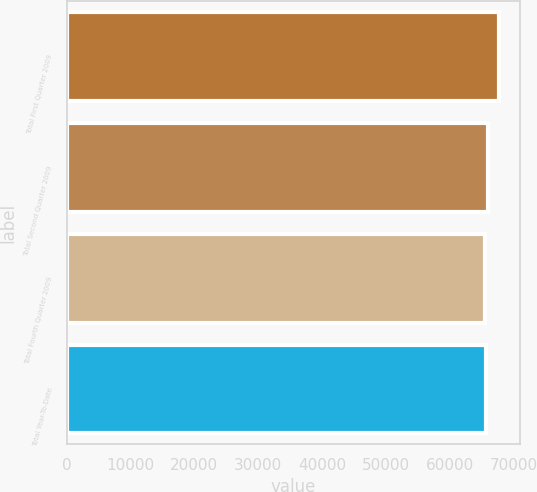Convert chart to OTSL. <chart><loc_0><loc_0><loc_500><loc_500><bar_chart><fcel>Total First Quarter 2009<fcel>Total Second Quarter 2009<fcel>Total Fourth Quarter 2009<fcel>Total Year-To-Date<nl><fcel>67657<fcel>65888.2<fcel>65446<fcel>65667.1<nl></chart> 